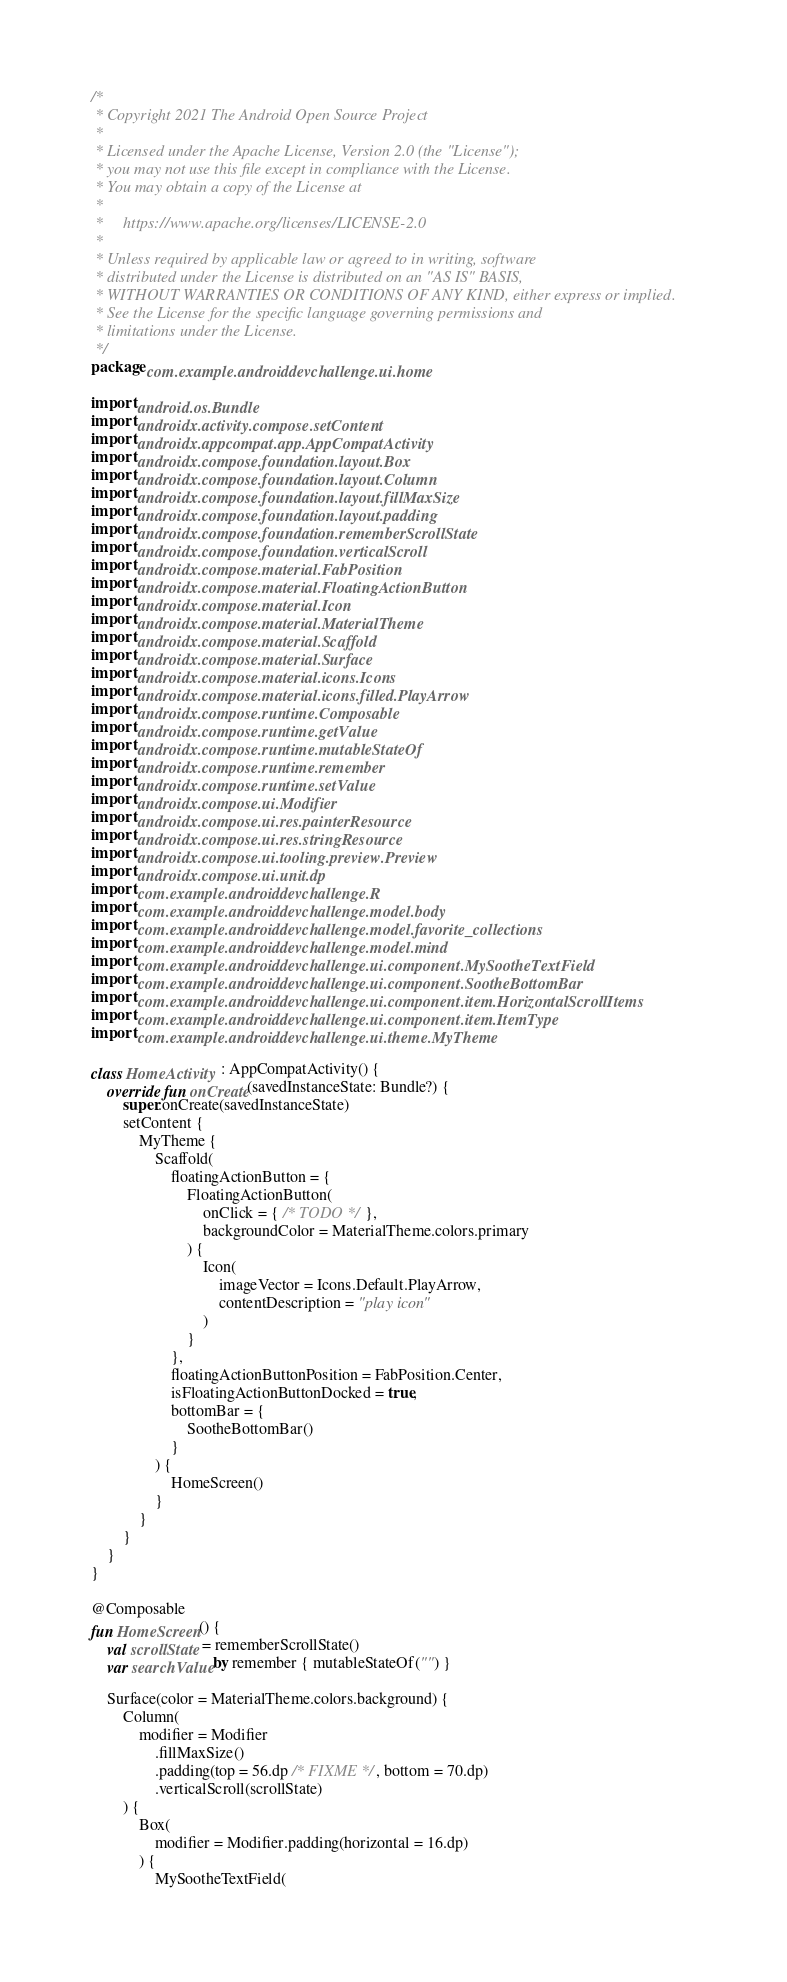<code> <loc_0><loc_0><loc_500><loc_500><_Kotlin_>/*
 * Copyright 2021 The Android Open Source Project
 *
 * Licensed under the Apache License, Version 2.0 (the "License");
 * you may not use this file except in compliance with the License.
 * You may obtain a copy of the License at
 *
 *     https://www.apache.org/licenses/LICENSE-2.0
 *
 * Unless required by applicable law or agreed to in writing, software
 * distributed under the License is distributed on an "AS IS" BASIS,
 * WITHOUT WARRANTIES OR CONDITIONS OF ANY KIND, either express or implied.
 * See the License for the specific language governing permissions and
 * limitations under the License.
 */
package com.example.androiddevchallenge.ui.home

import android.os.Bundle
import androidx.activity.compose.setContent
import androidx.appcompat.app.AppCompatActivity
import androidx.compose.foundation.layout.Box
import androidx.compose.foundation.layout.Column
import androidx.compose.foundation.layout.fillMaxSize
import androidx.compose.foundation.layout.padding
import androidx.compose.foundation.rememberScrollState
import androidx.compose.foundation.verticalScroll
import androidx.compose.material.FabPosition
import androidx.compose.material.FloatingActionButton
import androidx.compose.material.Icon
import androidx.compose.material.MaterialTheme
import androidx.compose.material.Scaffold
import androidx.compose.material.Surface
import androidx.compose.material.icons.Icons
import androidx.compose.material.icons.filled.PlayArrow
import androidx.compose.runtime.Composable
import androidx.compose.runtime.getValue
import androidx.compose.runtime.mutableStateOf
import androidx.compose.runtime.remember
import androidx.compose.runtime.setValue
import androidx.compose.ui.Modifier
import androidx.compose.ui.res.painterResource
import androidx.compose.ui.res.stringResource
import androidx.compose.ui.tooling.preview.Preview
import androidx.compose.ui.unit.dp
import com.example.androiddevchallenge.R
import com.example.androiddevchallenge.model.body
import com.example.androiddevchallenge.model.favorite_collections
import com.example.androiddevchallenge.model.mind
import com.example.androiddevchallenge.ui.component.MySootheTextField
import com.example.androiddevchallenge.ui.component.SootheBottomBar
import com.example.androiddevchallenge.ui.component.item.HorizontalScrollItems
import com.example.androiddevchallenge.ui.component.item.ItemType
import com.example.androiddevchallenge.ui.theme.MyTheme

class HomeActivity : AppCompatActivity() {
    override fun onCreate(savedInstanceState: Bundle?) {
        super.onCreate(savedInstanceState)
        setContent {
            MyTheme {
                Scaffold(
                    floatingActionButton = {
                        FloatingActionButton(
                            onClick = { /* TODO */ },
                            backgroundColor = MaterialTheme.colors.primary
                        ) {
                            Icon(
                                imageVector = Icons.Default.PlayArrow,
                                contentDescription = "play icon"
                            )
                        }
                    },
                    floatingActionButtonPosition = FabPosition.Center,
                    isFloatingActionButtonDocked = true,
                    bottomBar = {
                        SootheBottomBar()
                    }
                ) {
                    HomeScreen()
                }
            }
        }
    }
}

@Composable
fun HomeScreen() {
    val scrollState = rememberScrollState()
    var searchValue by remember { mutableStateOf("") }

    Surface(color = MaterialTheme.colors.background) {
        Column(
            modifier = Modifier
                .fillMaxSize()
                .padding(top = 56.dp /* FIXME */, bottom = 70.dp)
                .verticalScroll(scrollState)
        ) {
            Box(
                modifier = Modifier.padding(horizontal = 16.dp)
            ) {
                MySootheTextField(</code> 